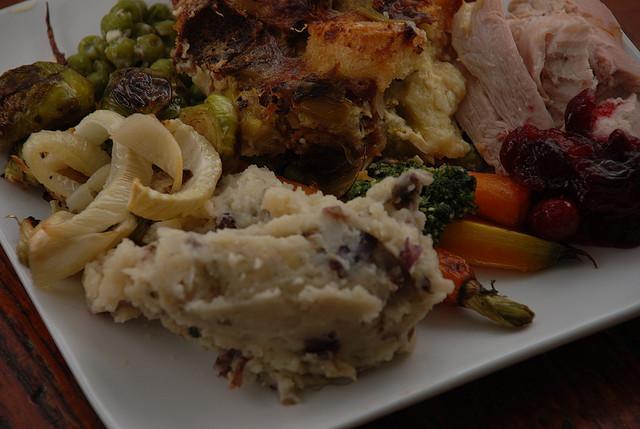How many carrots are visible?
Give a very brief answer. 2. How many vases are taller than the others?
Give a very brief answer. 0. 